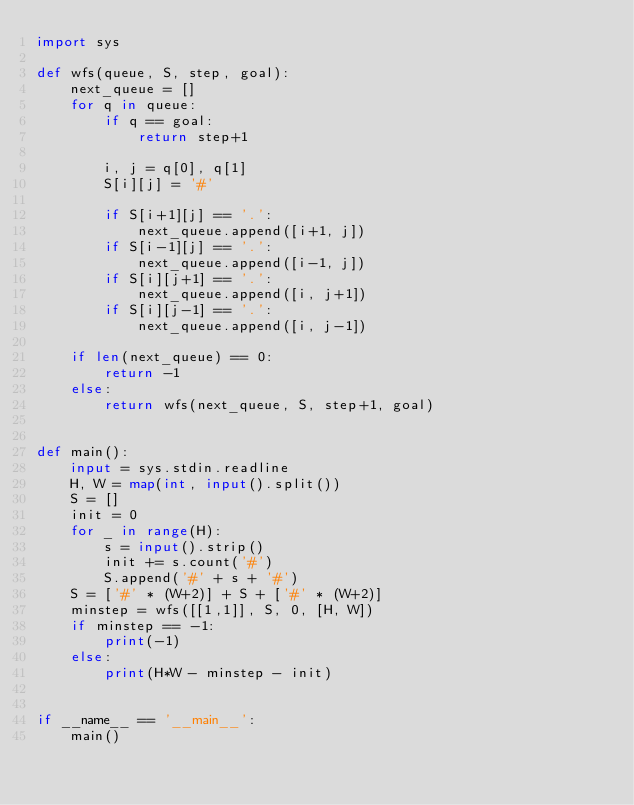Convert code to text. <code><loc_0><loc_0><loc_500><loc_500><_Python_>import sys

def wfs(queue, S, step, goal):
    next_queue = []
    for q in queue:
        if q == goal:
            return step+1

        i, j = q[0], q[1]
        S[i][j] = '#'

        if S[i+1][j] == '.':
            next_queue.append([i+1, j])
        if S[i-1][j] == '.':
            next_queue.append([i-1, j])
        if S[i][j+1] == '.':
            next_queue.append([i, j+1])
        if S[i][j-1] == '.':
            next_queue.append([i, j-1])

    if len(next_queue) == 0:
        return -1
    else:
        return wfs(next_queue, S, step+1, goal)


def main():
    input = sys.stdin.readline
    H, W = map(int, input().split())
    S = []
    init = 0
    for _ in range(H):
        s = input().strip()
        init += s.count('#')
        S.append('#' + s + '#')
    S = ['#' * (W+2)] + S + ['#' * (W+2)]
    minstep = wfs([[1,1]], S, 0, [H, W])
    if minstep == -1:
        print(-1)
    else:
        print(H*W - minstep - init)


if __name__ == '__main__':
    main()
</code> 